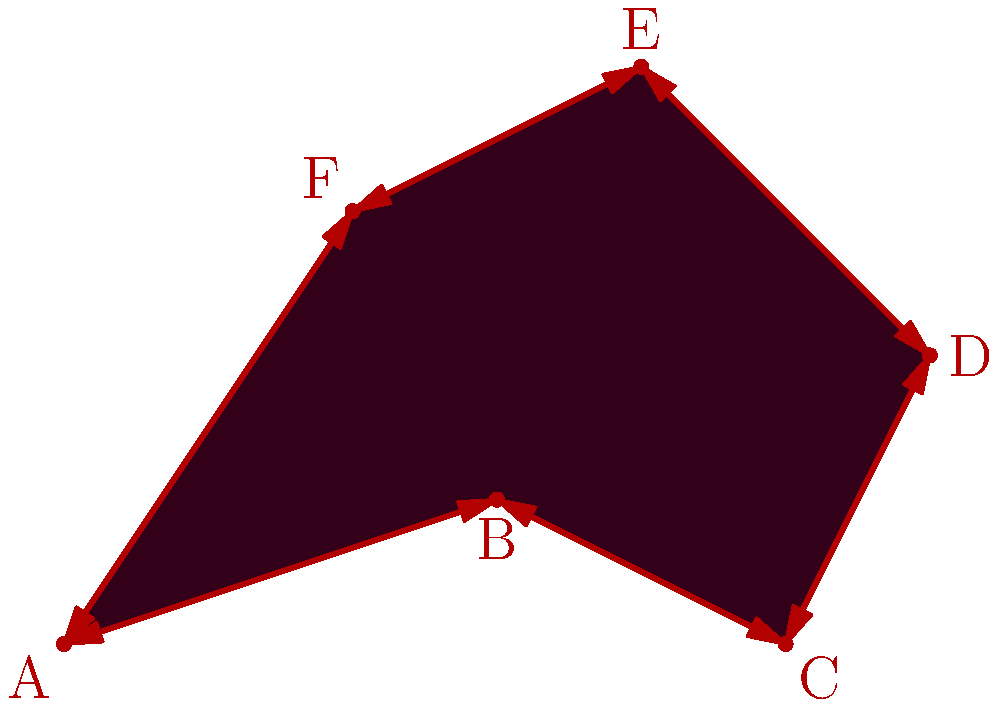In a dark, twisted landscape, a malevolent entity has carved out a jagged territory. The boundary of this cursed land forms an irregular hexagon ABCDEF, as shown in the eerie diagram. Given that AB = 3.16 units, BC = 2.24 units, CD = 2.83 units, DE = 2.83 units, EF = 2.83 units, and FA = 3.61 units, calculate the perimeter of this ominous shape. Round your answer to two decimal places. To find the perimeter of the irregular hexagon, we need to sum up the lengths of all its sides. The lengths are given as follows:

1. AB = 3.16 units
2. BC = 2.24 units
3. CD = 2.83 units
4. DE = 2.83 units
5. EF = 2.83 units
6. FA = 3.61 units

Let's add these lengths:

$$\text{Perimeter} = AB + BC + CD + DE + EF + FA$$
$$\text{Perimeter} = 3.16 + 2.24 + 2.83 + 2.83 + 2.83 + 3.61$$
$$\text{Perimeter} = 17.50 \text{ units}$$

Rounding to two decimal places, we get 17.50 units.
Answer: 17.50 units 